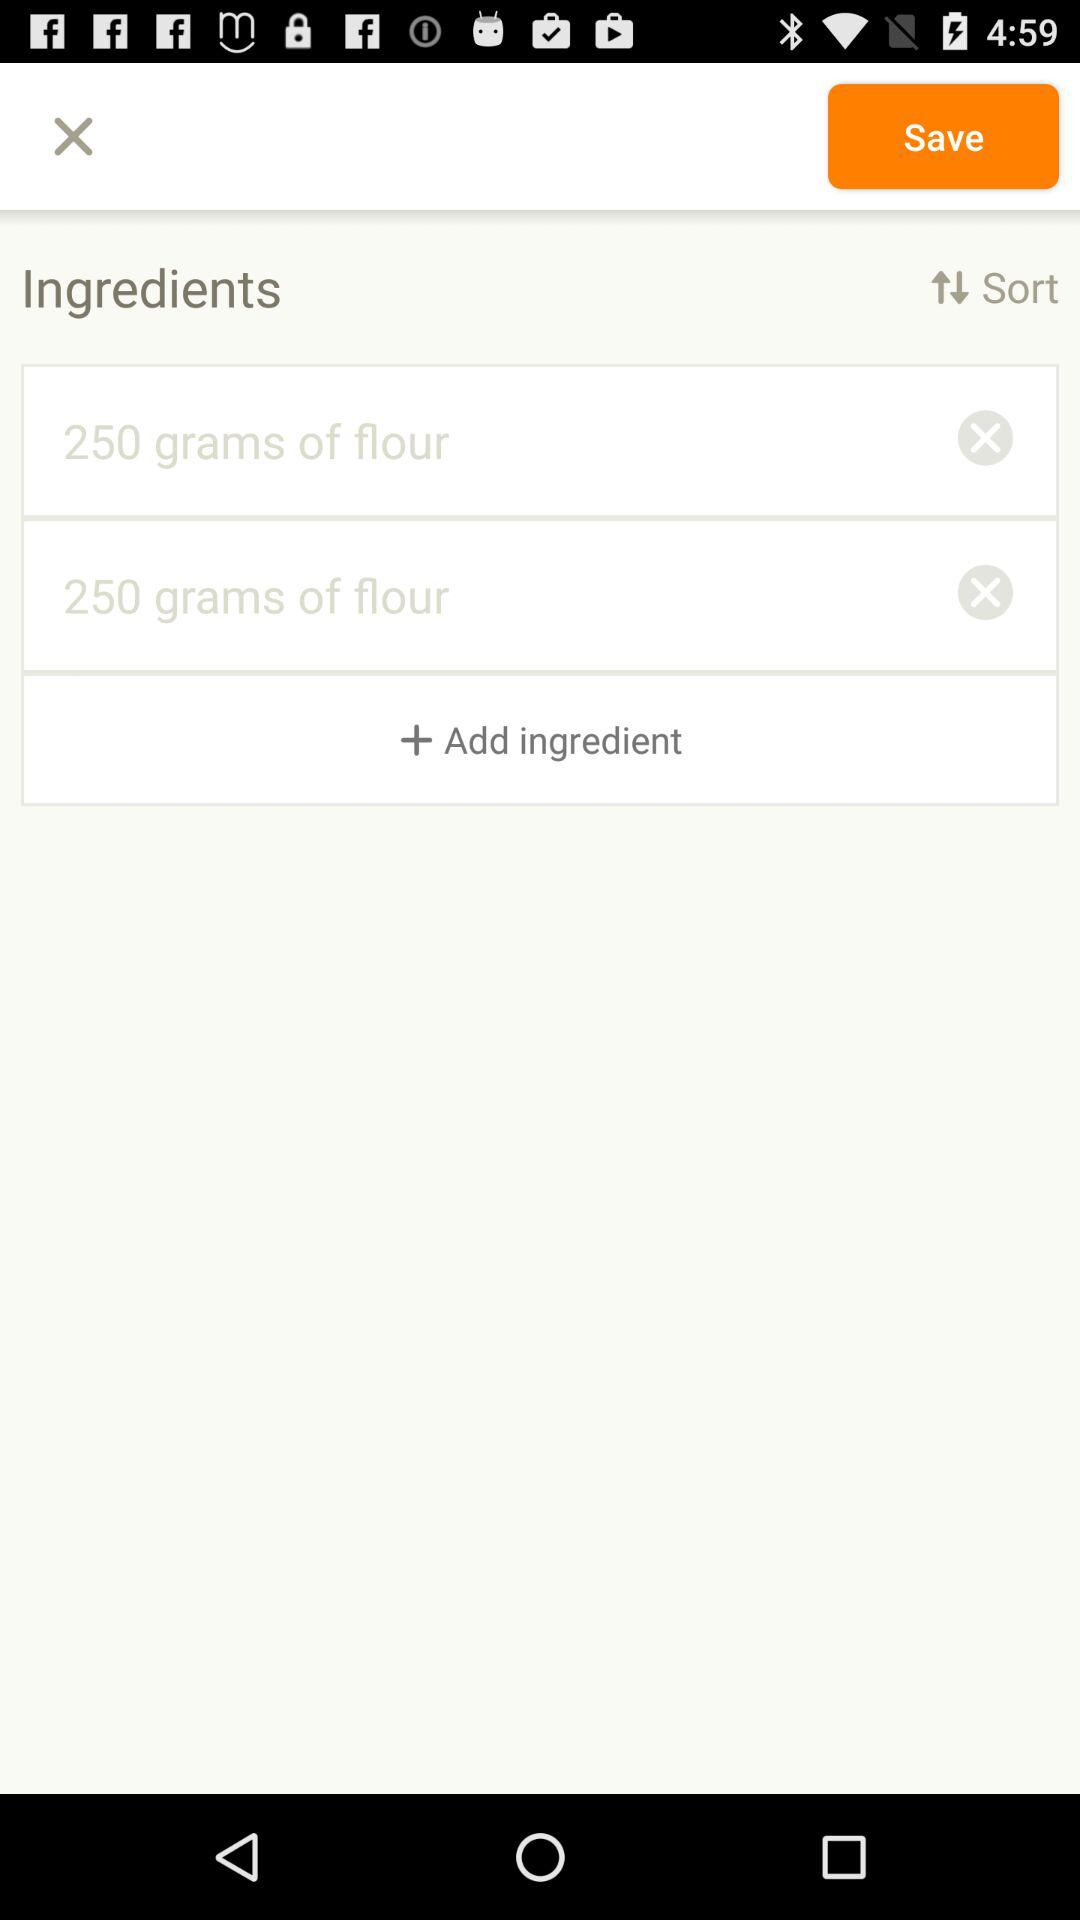How many calories are in 250 grams of flour?
When the provided information is insufficient, respond with <no answer>. <no answer> 